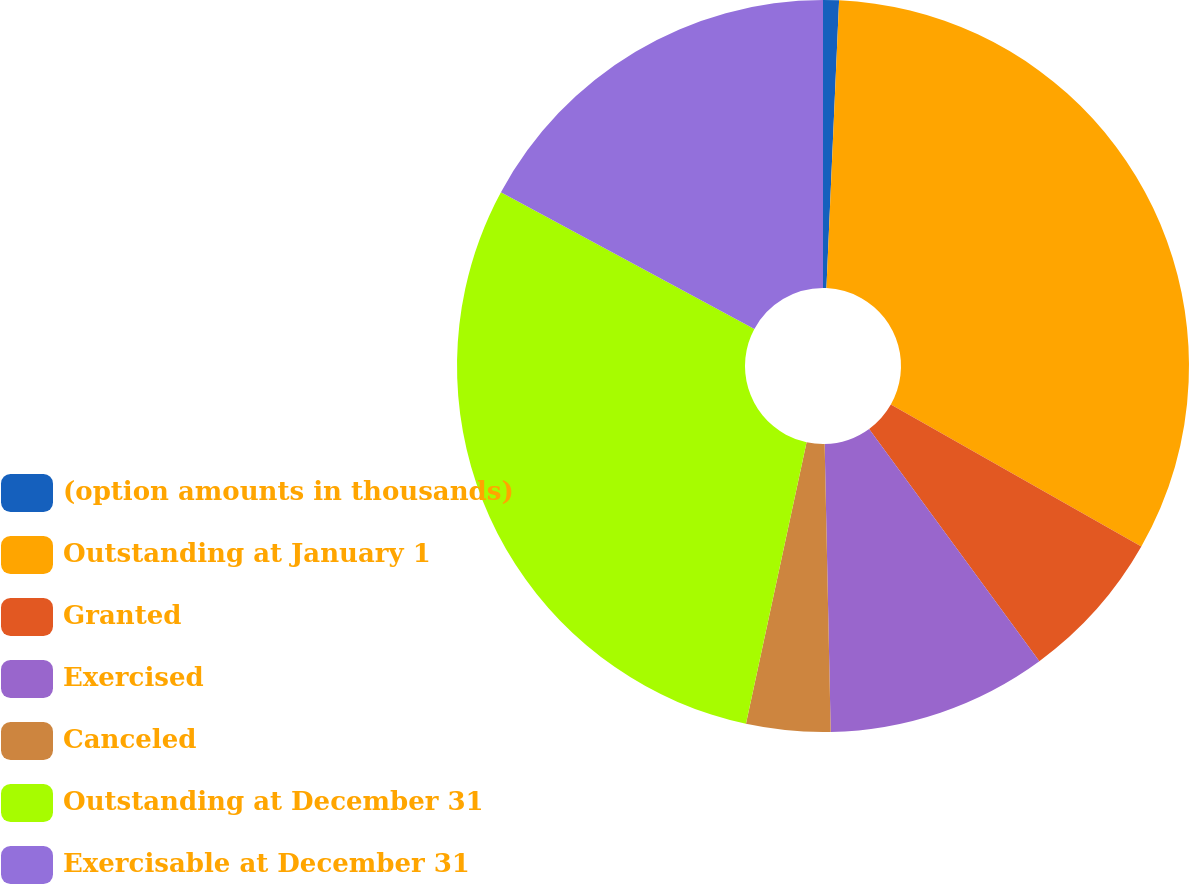Convert chart. <chart><loc_0><loc_0><loc_500><loc_500><pie_chart><fcel>(option amounts in thousands)<fcel>Outstanding at January 1<fcel>Granted<fcel>Exercised<fcel>Canceled<fcel>Outstanding at December 31<fcel>Exercisable at December 31<nl><fcel>0.7%<fcel>32.51%<fcel>6.72%<fcel>9.73%<fcel>3.71%<fcel>29.5%<fcel>17.12%<nl></chart> 